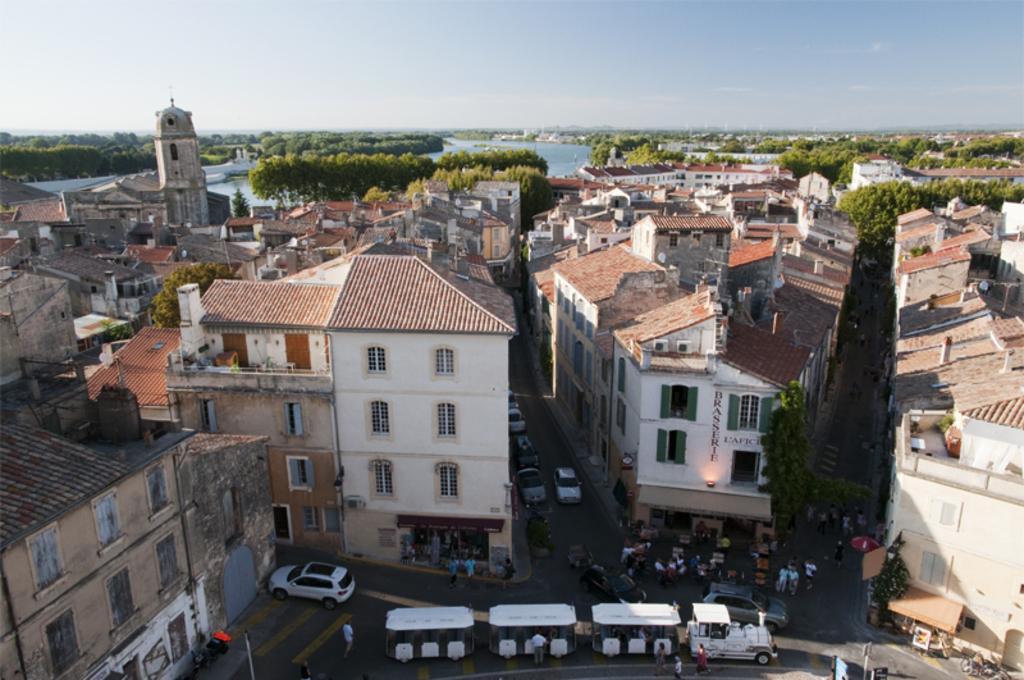In one or two sentences, can you explain what this image depicts? Here we can see buildings,windows,trees,water,antennas and clouds in the sky and there are vehicles,few people standing and walking on the road and we can also see some other objects on the road. 